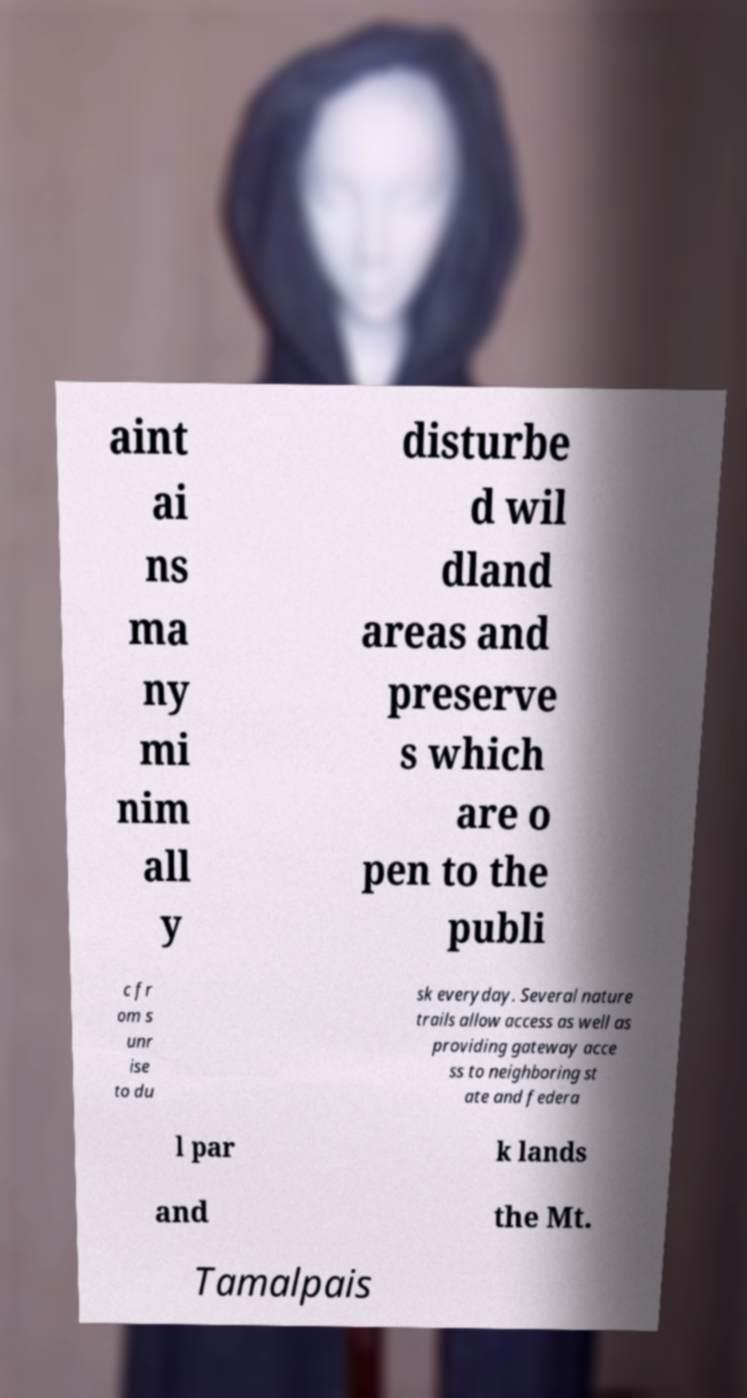Could you extract and type out the text from this image? aint ai ns ma ny mi nim all y disturbe d wil dland areas and preserve s which are o pen to the publi c fr om s unr ise to du sk everyday. Several nature trails allow access as well as providing gateway acce ss to neighboring st ate and federa l par k lands and the Mt. Tamalpais 